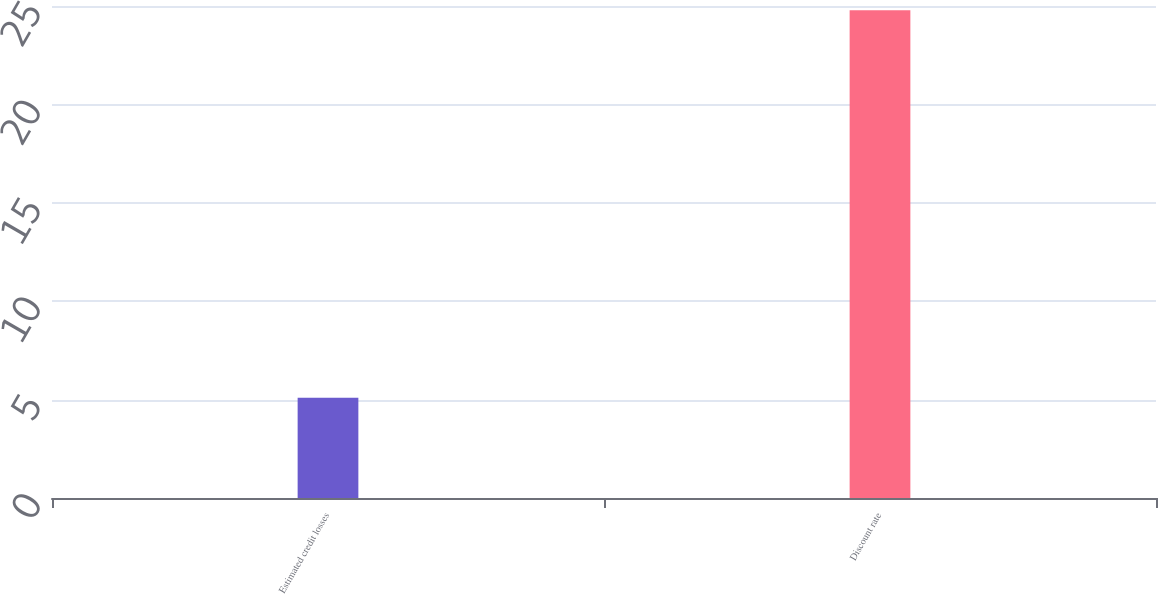Convert chart to OTSL. <chart><loc_0><loc_0><loc_500><loc_500><bar_chart><fcel>Estimated credit losses<fcel>Discount rate<nl><fcel>5.09<fcel>24.79<nl></chart> 